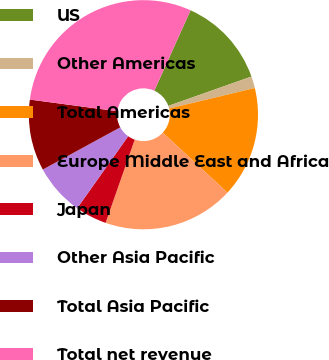Convert chart to OTSL. <chart><loc_0><loc_0><loc_500><loc_500><pie_chart><fcel>US<fcel>Other Americas<fcel>Total Americas<fcel>Europe Middle East and Africa<fcel>Japan<fcel>Other Asia Pacific<fcel>Total Asia Pacific<fcel>Total net revenue<nl><fcel>12.85%<fcel>1.66%<fcel>15.65%<fcel>18.45%<fcel>4.46%<fcel>7.25%<fcel>10.05%<fcel>29.64%<nl></chart> 